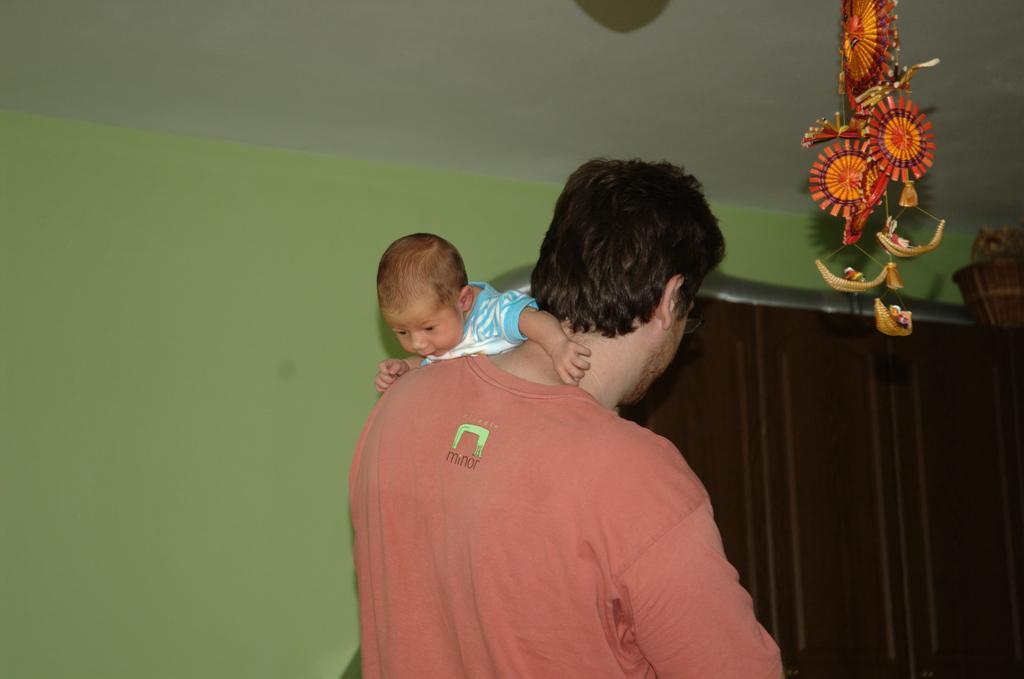In one or two sentences, can you explain what this image depicts? A man is carrying a baby. Here we can see a decorative item. Background there is a curtain, basket and green wall. 